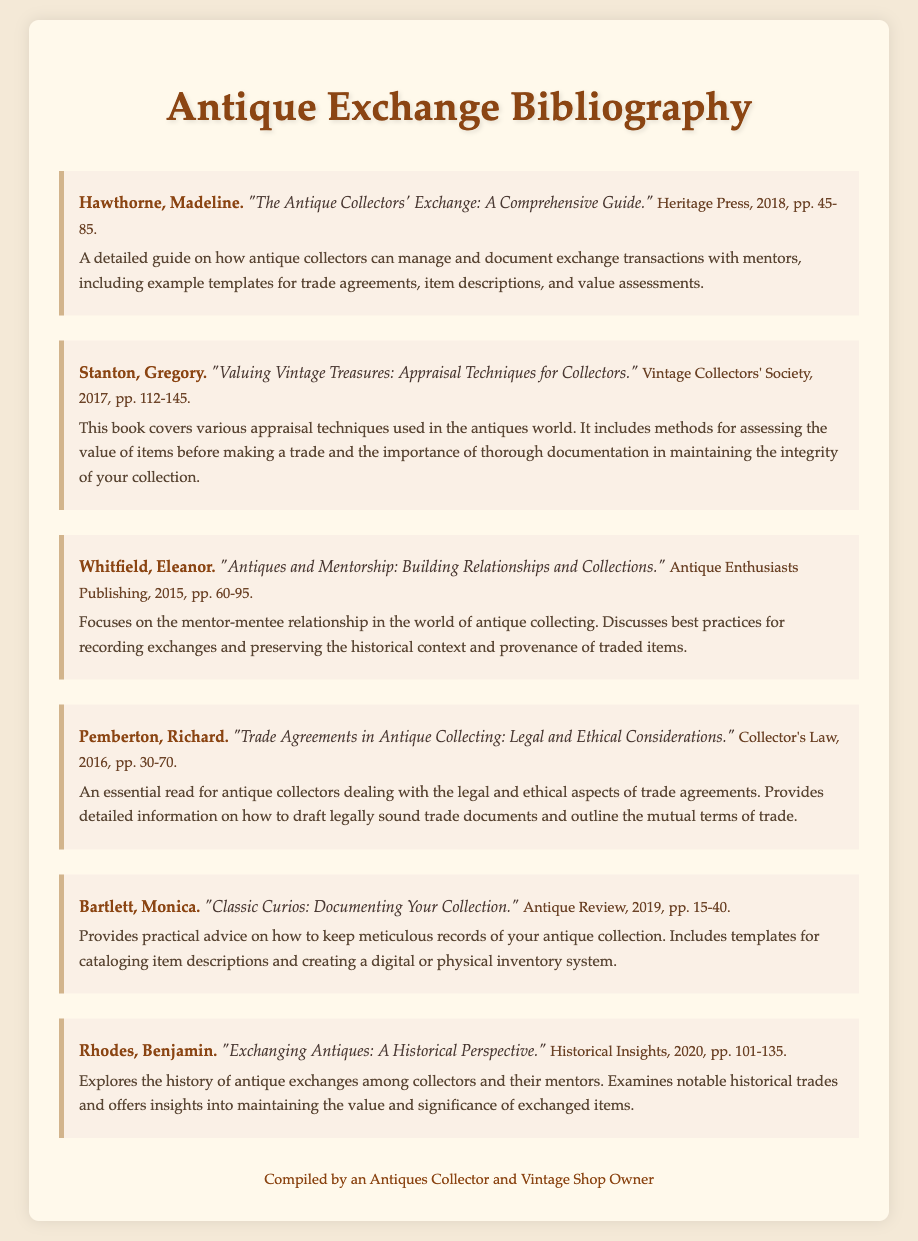What is the title of Madeline Hawthorne's book? The title is found in the bibliography item's description under her name.
Answer: "The Antique Collectors' Exchange: A Comprehensive Guide." Who published "Valuing Vintage Treasures"? The publisher's name is located in the publication info section of Gregory Stanton's book.
Answer: Vintage Collectors' Society In what year was "Antiques and Mentorship" published? The publication year is stated in the publication info of Eleanor Whitfield's entry.
Answer: 2015 What is the primary focus of Richard Pemberton's book? The primary focus is indicated in the description provided in his bibliography item.
Answer: Legal and ethical considerations How many pages does "Classic Curios" cover? The page range is mentioned in the publication info section of Monica Bartlett's book.
Answer: pp. 15-40 What type of document is this bibliography categorized under? This is a specific type of reference that lists sources for a particular theme or subject.
Answer: Bibliography What year was "Exchanging Antiques: A Historical Perspective" published? The publication year of Benjamin Rhodes' book can be found in the publication info section.
Answer: 2020 Which author discusses template examples for document exchanges? The author discussing documentation templates is specifically mentioned in the summary related to their work.
Answer: Madeline Hawthorne What is one key aspect discussed in "Trade Agreements in Antique Collecting"? The main topic is highlighted in the description, indicating significant content covered in the book.
Answer: Drafting legally sound trade documents 